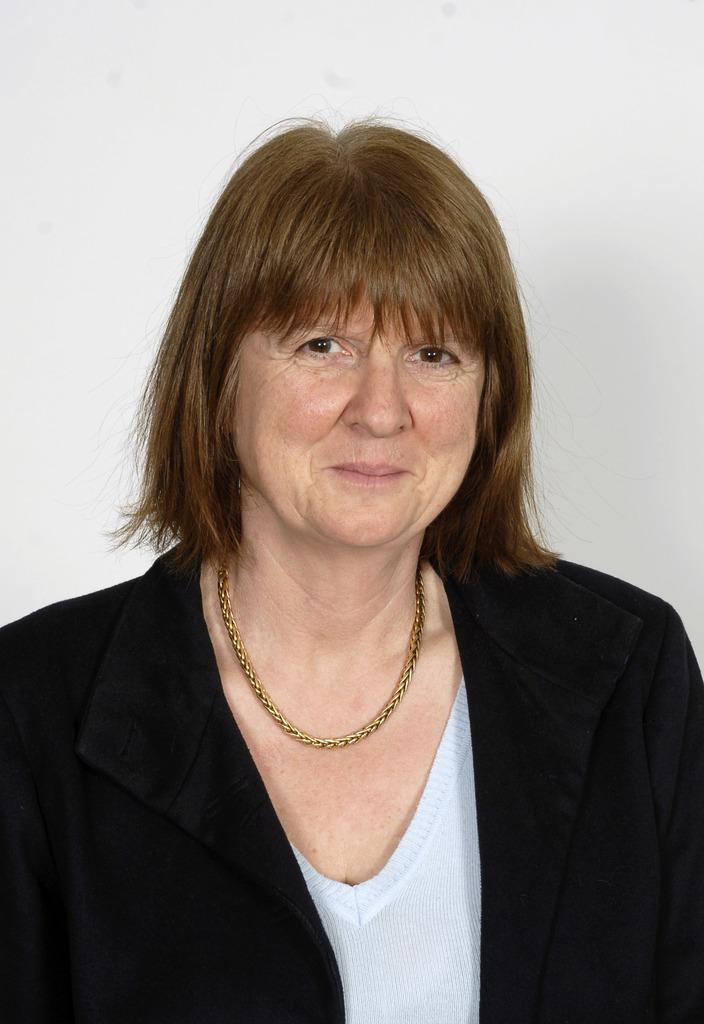Who is the main subject in the image? There is a woman in the image. What is the color of the woman's hair? The woman has brown hair. What type of clothing is the woman wearing on top? The woman is wearing a black coat. What type of clothing is the woman wearing underneath the coat? The woman is wearing a white t-shirt. What type of ear is the woman wearing in the image? The image does not show the woman wearing any earrings or other types of ear accessories. 